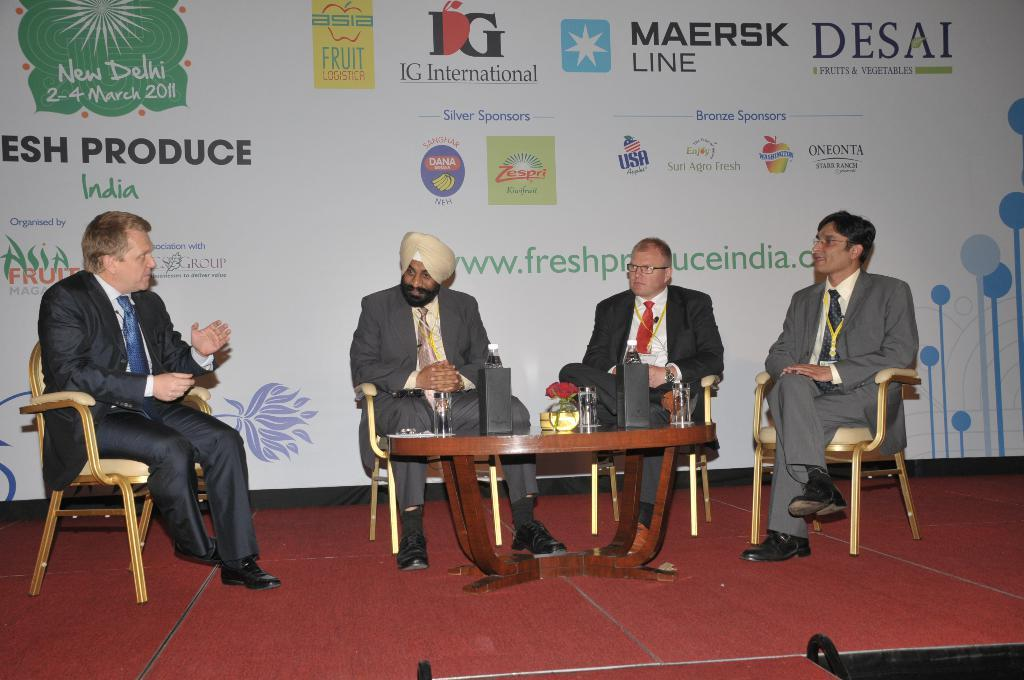How many people are in the image? There are four men in the image. What are the men doing in the image? The men are sitting on chairs. What is in front of the men? There is a table in front of the men. What is on the table? Two speakers are present on the table. What can be seen behind the men? There is a banner behind the men. How many trees can be seen behind the men in the image? There are no trees visible in the image; only a banner is present behind the men. What type of guitar is the man on the left playing in the image? There is no guitar present in the image; the men are sitting without any musical instruments. 